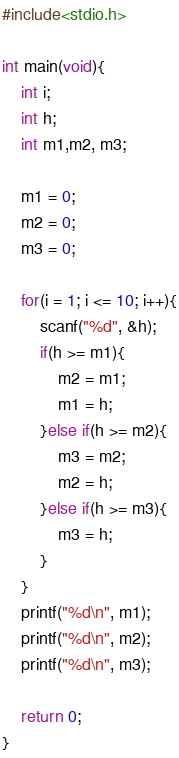<code> <loc_0><loc_0><loc_500><loc_500><_C_>#include<stdio.h>

int main(void){
	int i;
	int h;
	int m1,m2, m3;
	
	m1 = 0;
	m2 = 0;
	m3 = 0;
	
	for(i = 1; i <= 10; i++){
		scanf("%d", &h);
		if(h >= m1){
			m2 = m1;
			m1 = h;
		}else if(h >= m2){
			m3 = m2;
			m2 = h;
		}else if(h >= m3){
			m3 = h;
		}
	}
	printf("%d\n", m1);
	printf("%d\n", m2);
	printf("%d\n", m3);
	
	return 0;
}</code> 